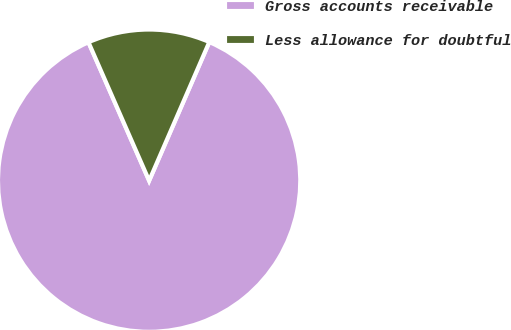Convert chart to OTSL. <chart><loc_0><loc_0><loc_500><loc_500><pie_chart><fcel>Gross accounts receivable<fcel>Less allowance for doubtful<nl><fcel>86.91%<fcel>13.09%<nl></chart> 